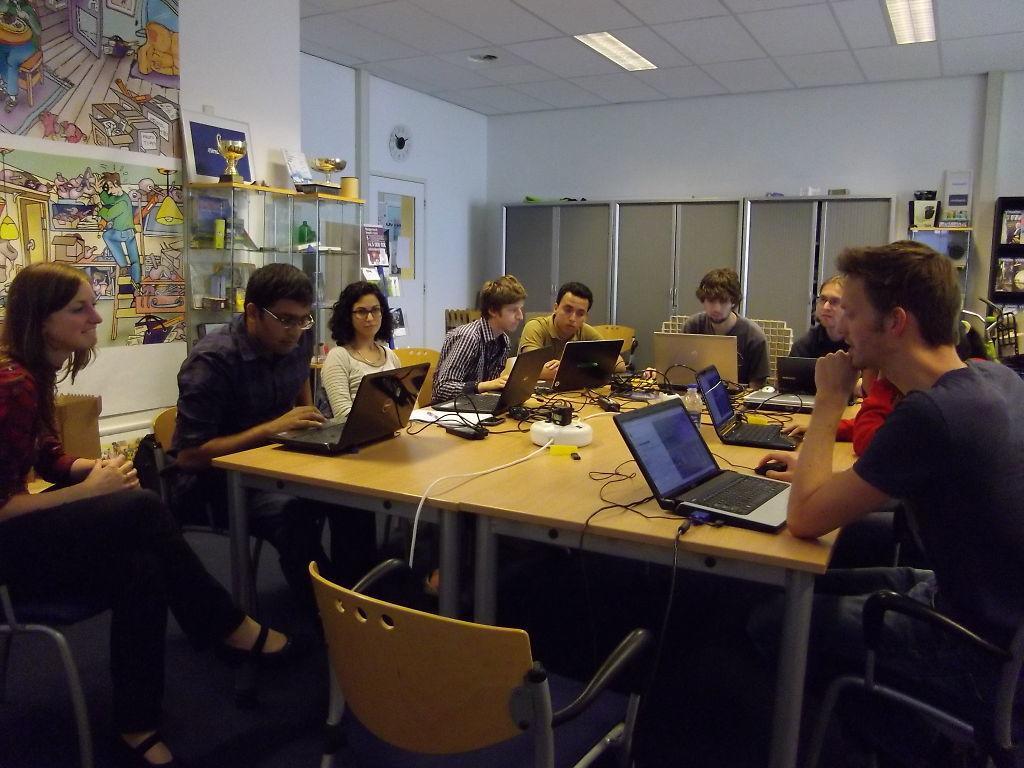Describe this image in one or two sentences. The image is clicked inside a room. There are many people sitting around the table. To the right, the man is wearing blue t-shirt and operating the laptop. To the left the woman is wearing red shirt and black pant. And she is also laughing. In the background there is a wall, cupboards, posters. At the top, there is a roof along with lights. 